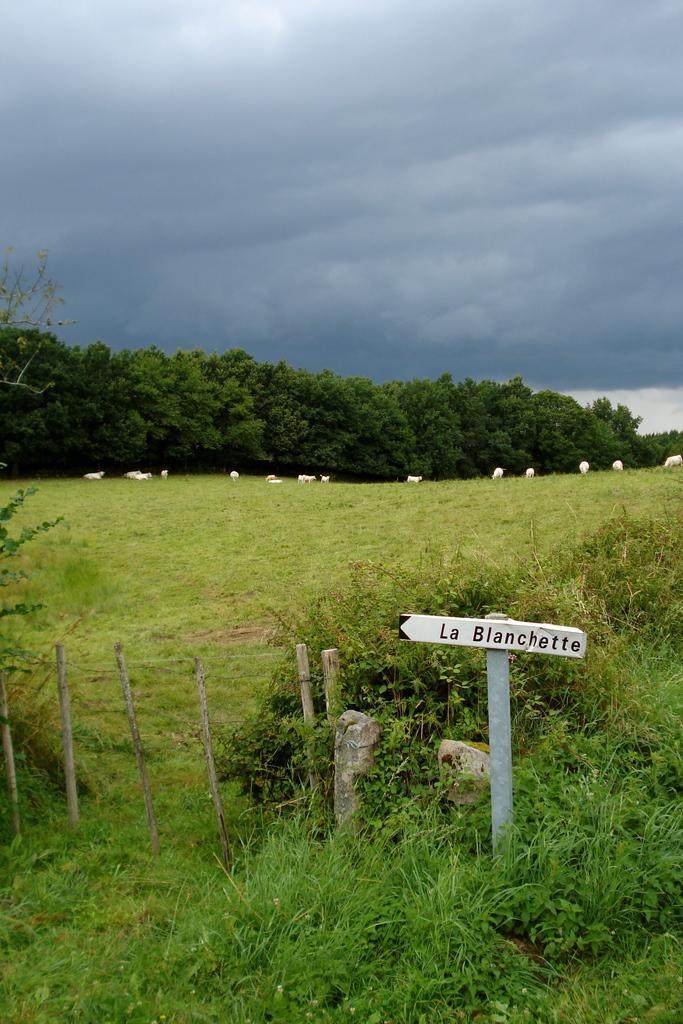Can you describe this image briefly? At the bottom of the image there is grass and a board. In the background there are trees and sky. 